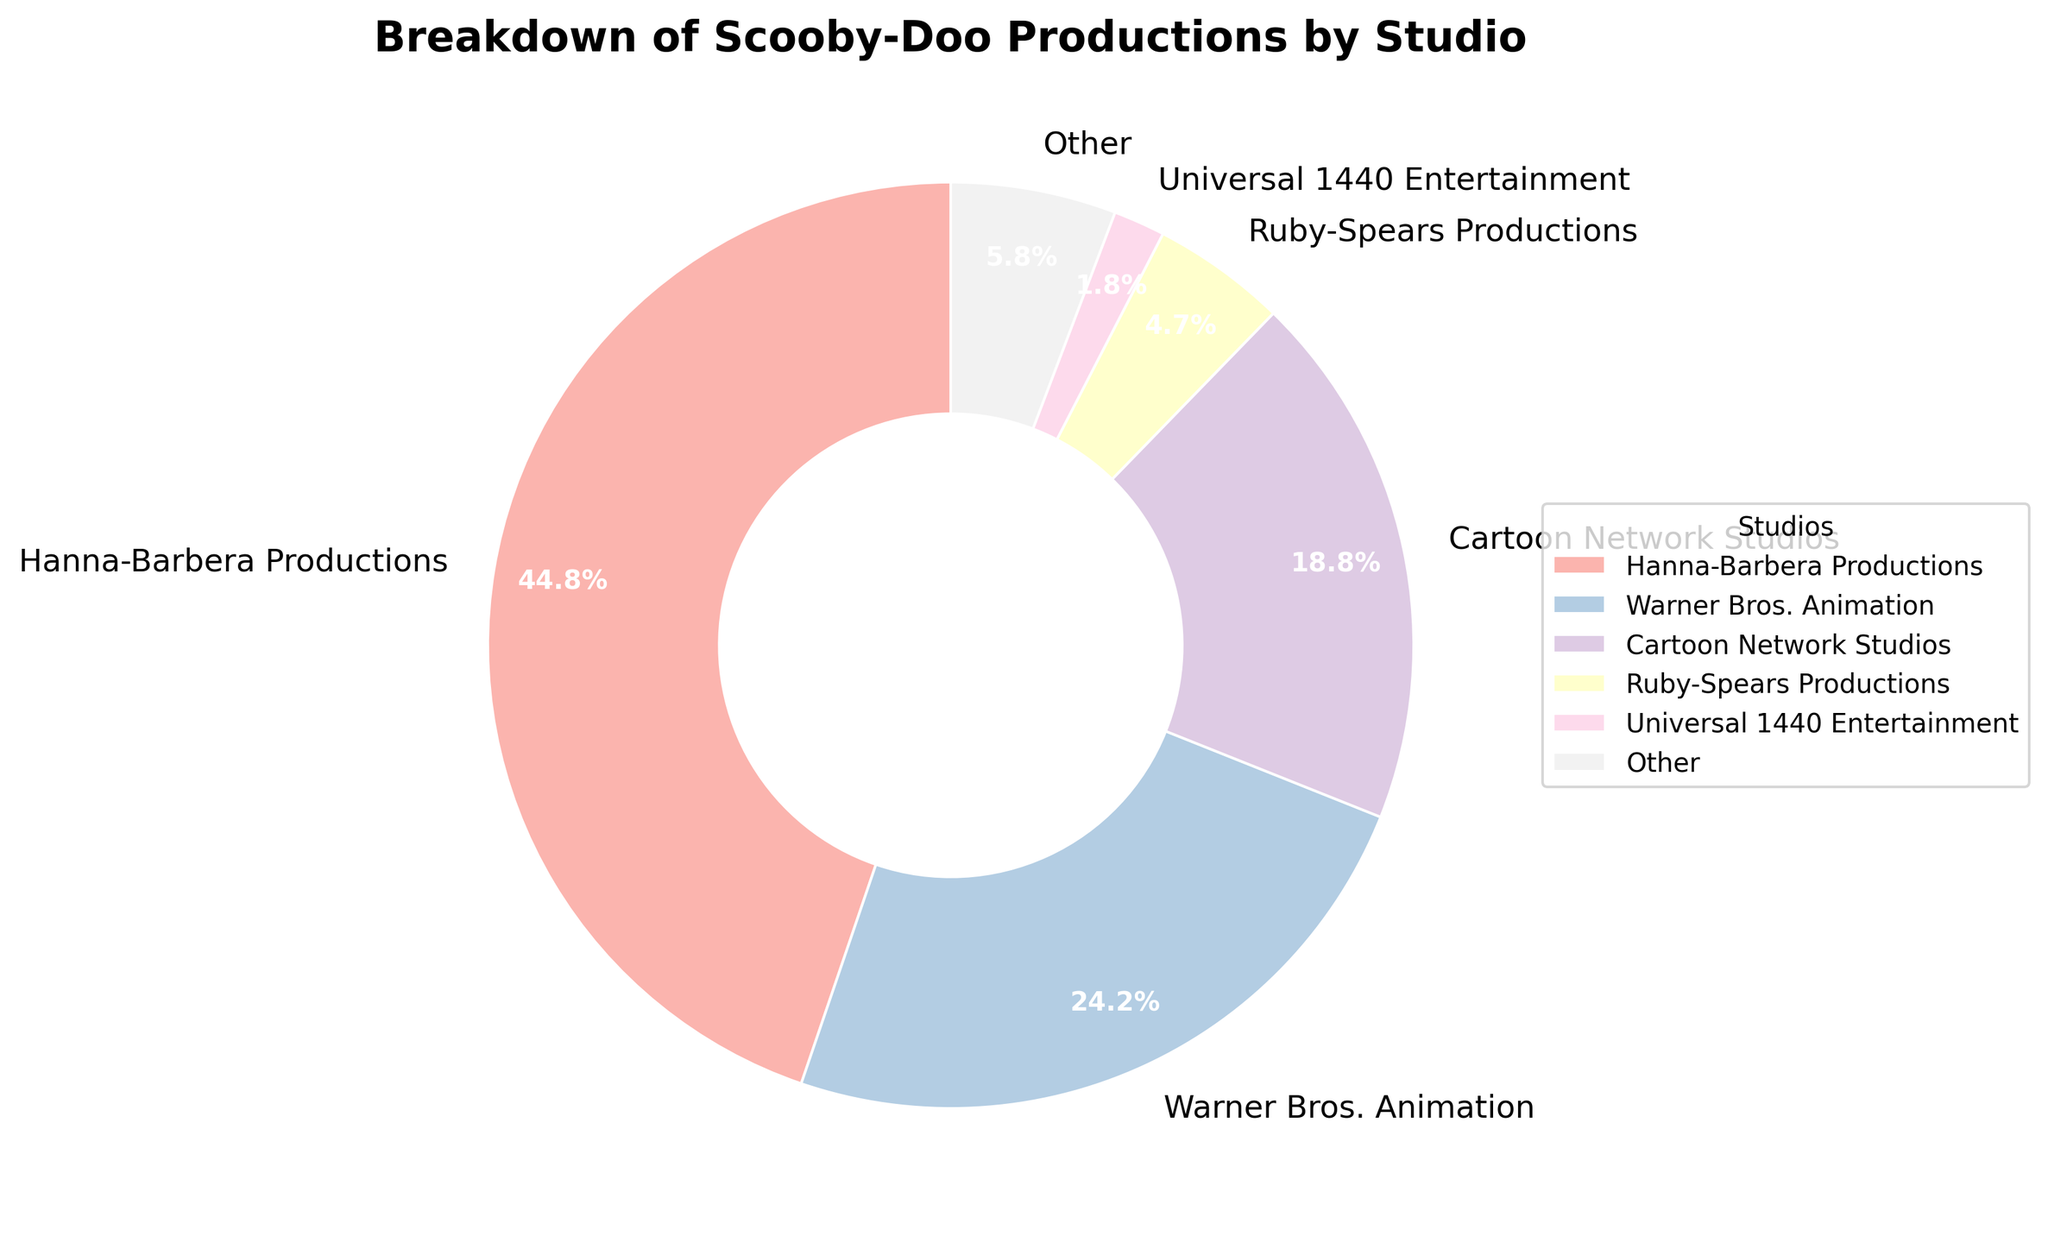What is the total number of Scooby-Doo productions by Hanna-Barbera Productions and Warner Bros. Animation combined? First, locate the values for Hanna-Barbera Productions (124) and Warner Bros. Animation (67). Sum these values: 124 + 67 = 191.
Answer: 191 Which studio has produced the fewest number of Scooby-Doo productions among those listed? The studios with less than 5 productions are grouped under "Other". Among the individually listed studios, Blue Ribbon Content and Warner Animation Group each have the smallest number with 1 production each.
Answer: Blue Ribbon Content and Warner Animation Group Which studio has the highest percentage of Scooby-Doo productions? The pie chart uses percentages for each studio. Hanna-Barbera Productions occupies the largest section of the pie chart, indicating the highest percentage of Scooby-Doo productions.
Answer: Hanna-Barbera Productions How many studios are included in the "Other" category, and what is their combined percentage? The "Other" category includes studios with fewer than 5 productions: DiC Entertainment (3), Teletoon (2), Warner Bros. Pictures (4), Atlas Entertainment (2), Warner Premiere (3), Blue Ribbon Content (1), Warner Animation Group (1). There are 7 studios in total. To find their combined percentage, add the number of productions: 3 + 2 + 4 + 2 + 3 + 1 + 1 = 16. The pie chart will also show the "Other" category's percentage directly.
Answer: 7 studios, a percentage directly available on the chart placeholder for "Other" What is the difference in the number of productions between Cartoon Network Studios and Ruby-Spears Productions? Identify the values for Cartoon Network Studios (52) and Ruby-Spears Productions (13). Subtract the smaller value from the larger value: 52 - 13 = 39.
Answer: 39 Which studio has approximately twice as many Scooby-Doo productions as Cartoon Network Studios? Identify the value for Cartoon Network Studios (52). Looking for a studio with approximately twice this value (52 * 2 = 104). Hanna-Barbera Productions has 124, which is roughly twice that of Cartoon Network Studios.
Answer: Hanna-Barbera Productions Can you identify the studio with the second largest share of Scooby-Doo productions? The largest share is by Hanna-Barbera Productions. The second largest segment of the pie chart, after Hanna-Barbera, is Warner Bros. Animation.
Answer: Warner Bros. Animation If you combine the productions of Universal 1440 Entertainment and Warner Bros. Pictures, how many productions would you have? Locate the values for Universal 1440 Entertainment (5) and Warner Bros. Pictures (4). Sum these values: 5 + 4 = 9.
Answer: 9 